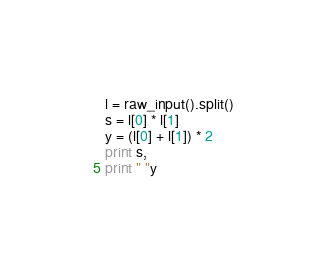Convert code to text. <code><loc_0><loc_0><loc_500><loc_500><_Python_>l = raw_input().split()
s = l[0] * l[1]
y = (l[0] + l[1]) * 2
print s,
print " "y</code> 